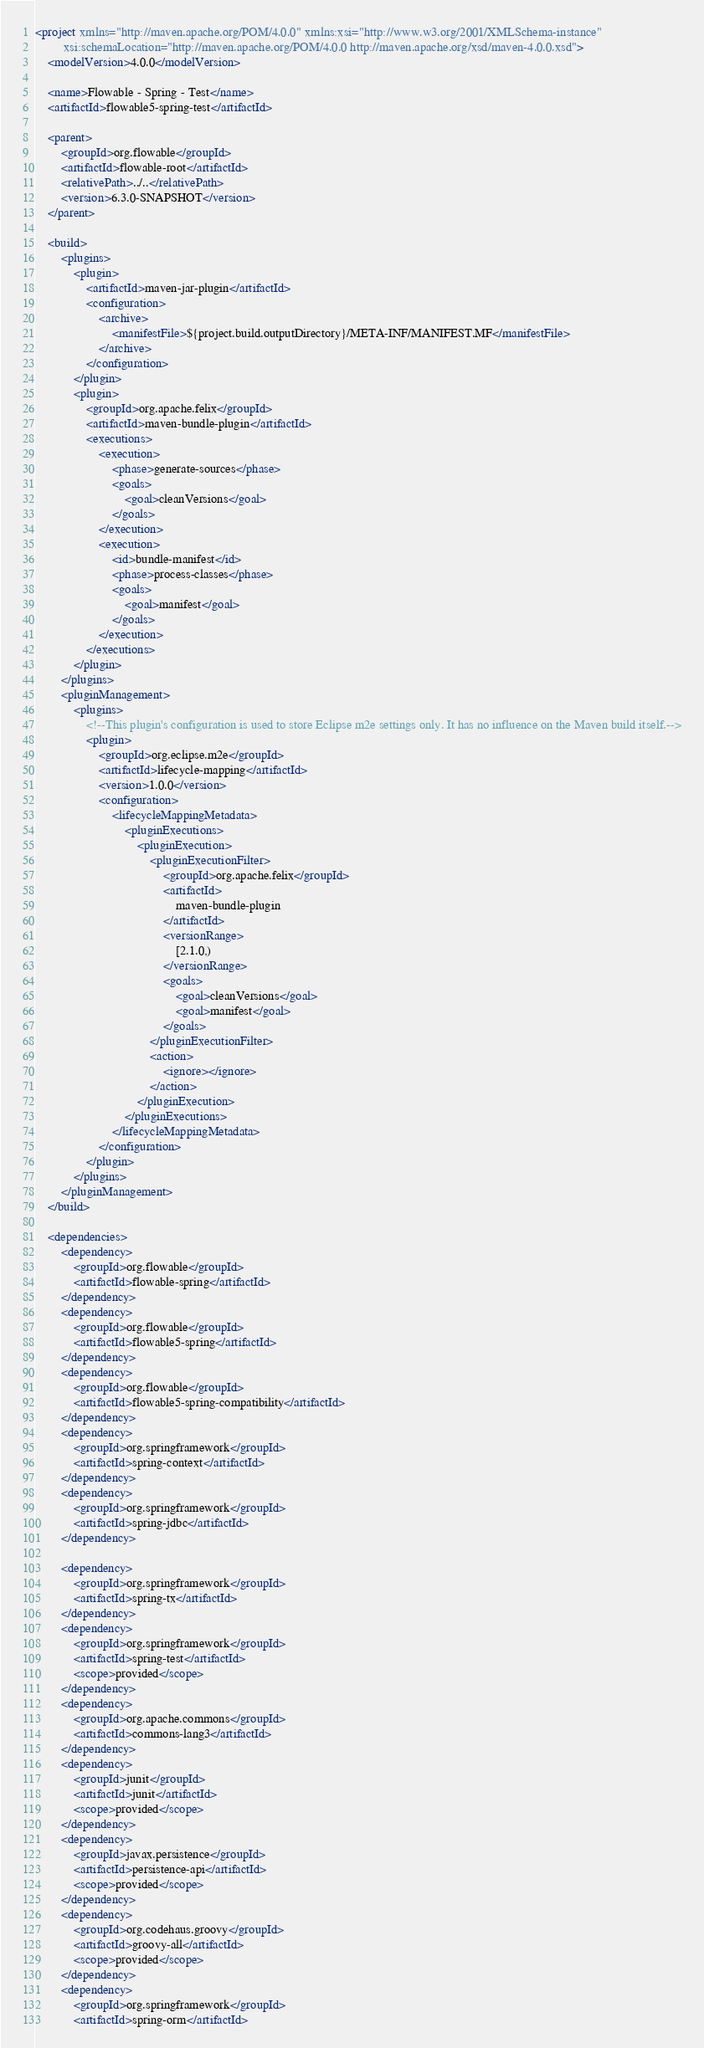Convert code to text. <code><loc_0><loc_0><loc_500><loc_500><_XML_><project xmlns="http://maven.apache.org/POM/4.0.0" xmlns:xsi="http://www.w3.org/2001/XMLSchema-instance"
         xsi:schemaLocation="http://maven.apache.org/POM/4.0.0 http://maven.apache.org/xsd/maven-4.0.0.xsd">
    <modelVersion>4.0.0</modelVersion>

    <name>Flowable - Spring - Test</name>
    <artifactId>flowable5-spring-test</artifactId>

    <parent>
        <groupId>org.flowable</groupId>
        <artifactId>flowable-root</artifactId>
        <relativePath>../..</relativePath>
        <version>6.3.0-SNAPSHOT</version>
    </parent>

    <build>
        <plugins>
            <plugin>
                <artifactId>maven-jar-plugin</artifactId>
                <configuration>
                    <archive>
                        <manifestFile>${project.build.outputDirectory}/META-INF/MANIFEST.MF</manifestFile>
                    </archive>
                </configuration>
            </plugin>
            <plugin>
                <groupId>org.apache.felix</groupId>
                <artifactId>maven-bundle-plugin</artifactId>
                <executions>
                    <execution>
                        <phase>generate-sources</phase>
                        <goals>
                            <goal>cleanVersions</goal>
                        </goals>
                    </execution>
                    <execution>
                        <id>bundle-manifest</id>
                        <phase>process-classes</phase>
                        <goals>
                            <goal>manifest</goal>
                        </goals>
                    </execution>
                </executions>
            </plugin>
        </plugins>
        <pluginManagement>
            <plugins>
                <!--This plugin's configuration is used to store Eclipse m2e settings only. It has no influence on the Maven build itself.-->
                <plugin>
                    <groupId>org.eclipse.m2e</groupId>
                    <artifactId>lifecycle-mapping</artifactId>
                    <version>1.0.0</version>
                    <configuration>
                        <lifecycleMappingMetadata>
                            <pluginExecutions>
                                <pluginExecution>
                                    <pluginExecutionFilter>
                                        <groupId>org.apache.felix</groupId>
                                        <artifactId>
                                            maven-bundle-plugin
                                        </artifactId>
                                        <versionRange>
                                            [2.1.0,)
                                        </versionRange>
                                        <goals>
                                            <goal>cleanVersions</goal>
                                            <goal>manifest</goal>
                                        </goals>
                                    </pluginExecutionFilter>
                                    <action>
                                        <ignore></ignore>
                                    </action>
                                </pluginExecution>
                            </pluginExecutions>
                        </lifecycleMappingMetadata>
                    </configuration>
                </plugin>
            </plugins>
        </pluginManagement>
    </build>

    <dependencies>
    	<dependency>
			<groupId>org.flowable</groupId>
			<artifactId>flowable-spring</artifactId>
		</dependency>
    	<dependency>
			<groupId>org.flowable</groupId>
			<artifactId>flowable5-spring</artifactId>
		</dependency>
        <dependency>
			<groupId>org.flowable</groupId>
			<artifactId>flowable5-spring-compatibility</artifactId>
		</dependency>
        <dependency>
            <groupId>org.springframework</groupId>
            <artifactId>spring-context</artifactId>
        </dependency>
        <dependency>
            <groupId>org.springframework</groupId>
            <artifactId>spring-jdbc</artifactId>
        </dependency>

        <dependency>
            <groupId>org.springframework</groupId>
            <artifactId>spring-tx</artifactId>
        </dependency>
        <dependency>
            <groupId>org.springframework</groupId>
            <artifactId>spring-test</artifactId>
            <scope>provided</scope>
        </dependency>
        <dependency>
            <groupId>org.apache.commons</groupId>
            <artifactId>commons-lang3</artifactId>
        </dependency>
        <dependency>
            <groupId>junit</groupId>
            <artifactId>junit</artifactId>
            <scope>provided</scope>
        </dependency>
        <dependency>
            <groupId>javax.persistence</groupId>
            <artifactId>persistence-api</artifactId>
            <scope>provided</scope>
        </dependency>
        <dependency>
            <groupId>org.codehaus.groovy</groupId>
            <artifactId>groovy-all</artifactId>
            <scope>provided</scope>
        </dependency>
        <dependency>
            <groupId>org.springframework</groupId>
            <artifactId>spring-orm</artifactId></code> 